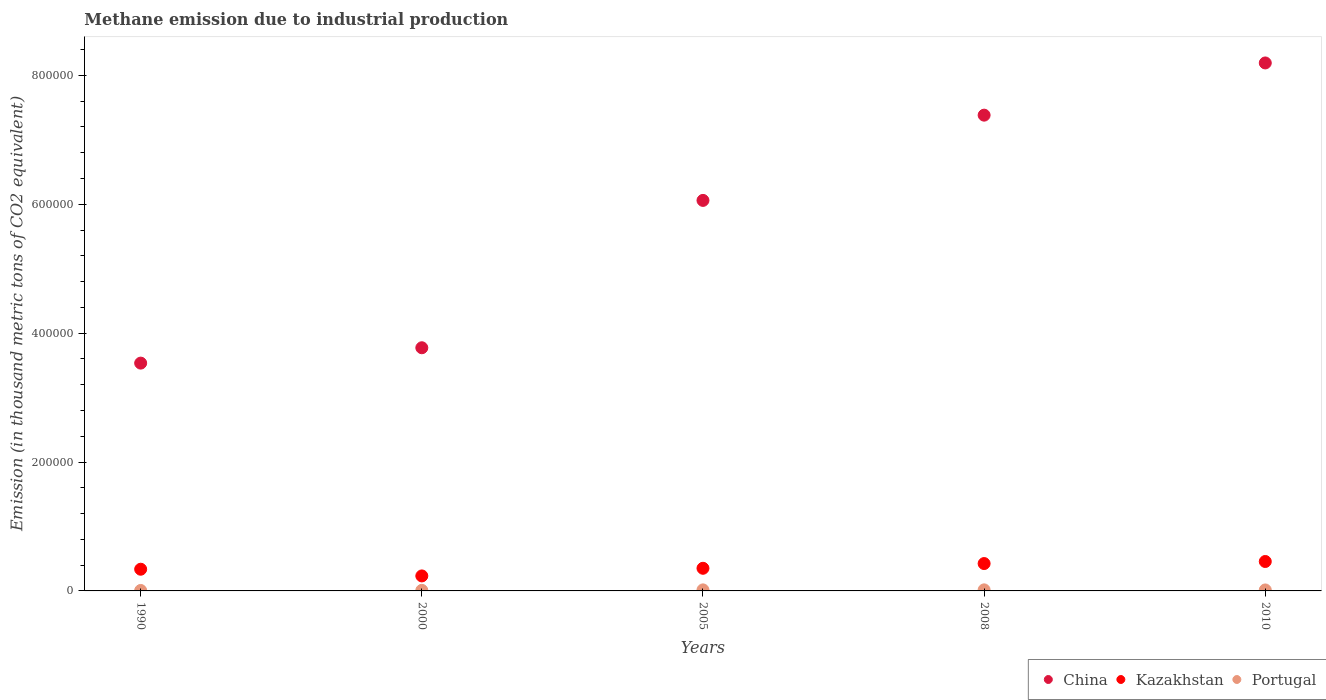What is the amount of methane emitted in China in 1990?
Give a very brief answer. 3.54e+05. Across all years, what is the maximum amount of methane emitted in Portugal?
Offer a terse response. 1651.1. Across all years, what is the minimum amount of methane emitted in Portugal?
Ensure brevity in your answer.  708.7. In which year was the amount of methane emitted in Kazakhstan minimum?
Ensure brevity in your answer.  2000. What is the total amount of methane emitted in Kazakhstan in the graph?
Your answer should be very brief. 1.80e+05. What is the difference between the amount of methane emitted in Kazakhstan in 1990 and that in 2008?
Make the answer very short. -8797.8. What is the difference between the amount of methane emitted in China in 2000 and the amount of methane emitted in Portugal in 2008?
Your answer should be compact. 3.76e+05. What is the average amount of methane emitted in Portugal per year?
Your response must be concise. 1279.18. In the year 1990, what is the difference between the amount of methane emitted in Kazakhstan and amount of methane emitted in China?
Give a very brief answer. -3.20e+05. In how many years, is the amount of methane emitted in Portugal greater than 600000 thousand metric tons?
Offer a very short reply. 0. What is the ratio of the amount of methane emitted in China in 2000 to that in 2008?
Provide a short and direct response. 0.51. Is the difference between the amount of methane emitted in Kazakhstan in 1990 and 2005 greater than the difference between the amount of methane emitted in China in 1990 and 2005?
Provide a succinct answer. Yes. What is the difference between the highest and the second highest amount of methane emitted in Portugal?
Your response must be concise. 36.1. What is the difference between the highest and the lowest amount of methane emitted in China?
Make the answer very short. 4.66e+05. In how many years, is the amount of methane emitted in Kazakhstan greater than the average amount of methane emitted in Kazakhstan taken over all years?
Keep it short and to the point. 2. Is the sum of the amount of methane emitted in Portugal in 1990 and 2000 greater than the maximum amount of methane emitted in Kazakhstan across all years?
Make the answer very short. No. Does the amount of methane emitted in China monotonically increase over the years?
Provide a succinct answer. Yes. Is the amount of methane emitted in Portugal strictly greater than the amount of methane emitted in Kazakhstan over the years?
Provide a short and direct response. No. Is the amount of methane emitted in China strictly less than the amount of methane emitted in Portugal over the years?
Offer a terse response. No. Are the values on the major ticks of Y-axis written in scientific E-notation?
Provide a succinct answer. No. Where does the legend appear in the graph?
Your response must be concise. Bottom right. How many legend labels are there?
Give a very brief answer. 3. How are the legend labels stacked?
Your answer should be compact. Horizontal. What is the title of the graph?
Provide a short and direct response. Methane emission due to industrial production. What is the label or title of the Y-axis?
Keep it short and to the point. Emission (in thousand metric tons of CO2 equivalent). What is the Emission (in thousand metric tons of CO2 equivalent) in China in 1990?
Ensure brevity in your answer.  3.54e+05. What is the Emission (in thousand metric tons of CO2 equivalent) in Kazakhstan in 1990?
Make the answer very short. 3.37e+04. What is the Emission (in thousand metric tons of CO2 equivalent) of Portugal in 1990?
Your answer should be very brief. 708.7. What is the Emission (in thousand metric tons of CO2 equivalent) of China in 2000?
Your response must be concise. 3.77e+05. What is the Emission (in thousand metric tons of CO2 equivalent) in Kazakhstan in 2000?
Make the answer very short. 2.33e+04. What is the Emission (in thousand metric tons of CO2 equivalent) of Portugal in 2000?
Make the answer very short. 909.6. What is the Emission (in thousand metric tons of CO2 equivalent) in China in 2005?
Ensure brevity in your answer.  6.06e+05. What is the Emission (in thousand metric tons of CO2 equivalent) of Kazakhstan in 2005?
Offer a terse response. 3.51e+04. What is the Emission (in thousand metric tons of CO2 equivalent) of Portugal in 2005?
Offer a very short reply. 1615. What is the Emission (in thousand metric tons of CO2 equivalent) of China in 2008?
Provide a succinct answer. 7.38e+05. What is the Emission (in thousand metric tons of CO2 equivalent) in Kazakhstan in 2008?
Ensure brevity in your answer.  4.25e+04. What is the Emission (in thousand metric tons of CO2 equivalent) of Portugal in 2008?
Your answer should be very brief. 1651.1. What is the Emission (in thousand metric tons of CO2 equivalent) in China in 2010?
Ensure brevity in your answer.  8.19e+05. What is the Emission (in thousand metric tons of CO2 equivalent) of Kazakhstan in 2010?
Keep it short and to the point. 4.57e+04. What is the Emission (in thousand metric tons of CO2 equivalent) in Portugal in 2010?
Your answer should be compact. 1511.5. Across all years, what is the maximum Emission (in thousand metric tons of CO2 equivalent) in China?
Keep it short and to the point. 8.19e+05. Across all years, what is the maximum Emission (in thousand metric tons of CO2 equivalent) in Kazakhstan?
Ensure brevity in your answer.  4.57e+04. Across all years, what is the maximum Emission (in thousand metric tons of CO2 equivalent) in Portugal?
Your answer should be very brief. 1651.1. Across all years, what is the minimum Emission (in thousand metric tons of CO2 equivalent) in China?
Provide a succinct answer. 3.54e+05. Across all years, what is the minimum Emission (in thousand metric tons of CO2 equivalent) of Kazakhstan?
Ensure brevity in your answer.  2.33e+04. Across all years, what is the minimum Emission (in thousand metric tons of CO2 equivalent) of Portugal?
Offer a very short reply. 708.7. What is the total Emission (in thousand metric tons of CO2 equivalent) of China in the graph?
Keep it short and to the point. 2.89e+06. What is the total Emission (in thousand metric tons of CO2 equivalent) of Kazakhstan in the graph?
Provide a succinct answer. 1.80e+05. What is the total Emission (in thousand metric tons of CO2 equivalent) of Portugal in the graph?
Your answer should be compact. 6395.9. What is the difference between the Emission (in thousand metric tons of CO2 equivalent) in China in 1990 and that in 2000?
Provide a succinct answer. -2.38e+04. What is the difference between the Emission (in thousand metric tons of CO2 equivalent) in Kazakhstan in 1990 and that in 2000?
Offer a terse response. 1.04e+04. What is the difference between the Emission (in thousand metric tons of CO2 equivalent) in Portugal in 1990 and that in 2000?
Give a very brief answer. -200.9. What is the difference between the Emission (in thousand metric tons of CO2 equivalent) in China in 1990 and that in 2005?
Your response must be concise. -2.53e+05. What is the difference between the Emission (in thousand metric tons of CO2 equivalent) of Kazakhstan in 1990 and that in 2005?
Make the answer very short. -1456.8. What is the difference between the Emission (in thousand metric tons of CO2 equivalent) in Portugal in 1990 and that in 2005?
Your response must be concise. -906.3. What is the difference between the Emission (in thousand metric tons of CO2 equivalent) of China in 1990 and that in 2008?
Offer a terse response. -3.85e+05. What is the difference between the Emission (in thousand metric tons of CO2 equivalent) in Kazakhstan in 1990 and that in 2008?
Keep it short and to the point. -8797.8. What is the difference between the Emission (in thousand metric tons of CO2 equivalent) of Portugal in 1990 and that in 2008?
Provide a short and direct response. -942.4. What is the difference between the Emission (in thousand metric tons of CO2 equivalent) of China in 1990 and that in 2010?
Provide a succinct answer. -4.66e+05. What is the difference between the Emission (in thousand metric tons of CO2 equivalent) of Kazakhstan in 1990 and that in 2010?
Make the answer very short. -1.20e+04. What is the difference between the Emission (in thousand metric tons of CO2 equivalent) of Portugal in 1990 and that in 2010?
Provide a short and direct response. -802.8. What is the difference between the Emission (in thousand metric tons of CO2 equivalent) of China in 2000 and that in 2005?
Your answer should be very brief. -2.29e+05. What is the difference between the Emission (in thousand metric tons of CO2 equivalent) of Kazakhstan in 2000 and that in 2005?
Provide a succinct answer. -1.19e+04. What is the difference between the Emission (in thousand metric tons of CO2 equivalent) of Portugal in 2000 and that in 2005?
Ensure brevity in your answer.  -705.4. What is the difference between the Emission (in thousand metric tons of CO2 equivalent) of China in 2000 and that in 2008?
Your answer should be very brief. -3.61e+05. What is the difference between the Emission (in thousand metric tons of CO2 equivalent) in Kazakhstan in 2000 and that in 2008?
Your answer should be compact. -1.92e+04. What is the difference between the Emission (in thousand metric tons of CO2 equivalent) in Portugal in 2000 and that in 2008?
Provide a succinct answer. -741.5. What is the difference between the Emission (in thousand metric tons of CO2 equivalent) in China in 2000 and that in 2010?
Offer a very short reply. -4.42e+05. What is the difference between the Emission (in thousand metric tons of CO2 equivalent) in Kazakhstan in 2000 and that in 2010?
Keep it short and to the point. -2.24e+04. What is the difference between the Emission (in thousand metric tons of CO2 equivalent) in Portugal in 2000 and that in 2010?
Your response must be concise. -601.9. What is the difference between the Emission (in thousand metric tons of CO2 equivalent) in China in 2005 and that in 2008?
Give a very brief answer. -1.32e+05. What is the difference between the Emission (in thousand metric tons of CO2 equivalent) of Kazakhstan in 2005 and that in 2008?
Offer a very short reply. -7341. What is the difference between the Emission (in thousand metric tons of CO2 equivalent) of Portugal in 2005 and that in 2008?
Offer a terse response. -36.1. What is the difference between the Emission (in thousand metric tons of CO2 equivalent) in China in 2005 and that in 2010?
Give a very brief answer. -2.13e+05. What is the difference between the Emission (in thousand metric tons of CO2 equivalent) in Kazakhstan in 2005 and that in 2010?
Make the answer very short. -1.05e+04. What is the difference between the Emission (in thousand metric tons of CO2 equivalent) of Portugal in 2005 and that in 2010?
Keep it short and to the point. 103.5. What is the difference between the Emission (in thousand metric tons of CO2 equivalent) in China in 2008 and that in 2010?
Offer a terse response. -8.10e+04. What is the difference between the Emission (in thousand metric tons of CO2 equivalent) of Kazakhstan in 2008 and that in 2010?
Make the answer very short. -3195. What is the difference between the Emission (in thousand metric tons of CO2 equivalent) in Portugal in 2008 and that in 2010?
Offer a very short reply. 139.6. What is the difference between the Emission (in thousand metric tons of CO2 equivalent) of China in 1990 and the Emission (in thousand metric tons of CO2 equivalent) of Kazakhstan in 2000?
Keep it short and to the point. 3.30e+05. What is the difference between the Emission (in thousand metric tons of CO2 equivalent) in China in 1990 and the Emission (in thousand metric tons of CO2 equivalent) in Portugal in 2000?
Your answer should be compact. 3.53e+05. What is the difference between the Emission (in thousand metric tons of CO2 equivalent) in Kazakhstan in 1990 and the Emission (in thousand metric tons of CO2 equivalent) in Portugal in 2000?
Your response must be concise. 3.28e+04. What is the difference between the Emission (in thousand metric tons of CO2 equivalent) of China in 1990 and the Emission (in thousand metric tons of CO2 equivalent) of Kazakhstan in 2005?
Give a very brief answer. 3.18e+05. What is the difference between the Emission (in thousand metric tons of CO2 equivalent) in China in 1990 and the Emission (in thousand metric tons of CO2 equivalent) in Portugal in 2005?
Your response must be concise. 3.52e+05. What is the difference between the Emission (in thousand metric tons of CO2 equivalent) of Kazakhstan in 1990 and the Emission (in thousand metric tons of CO2 equivalent) of Portugal in 2005?
Keep it short and to the point. 3.21e+04. What is the difference between the Emission (in thousand metric tons of CO2 equivalent) of China in 1990 and the Emission (in thousand metric tons of CO2 equivalent) of Kazakhstan in 2008?
Your response must be concise. 3.11e+05. What is the difference between the Emission (in thousand metric tons of CO2 equivalent) in China in 1990 and the Emission (in thousand metric tons of CO2 equivalent) in Portugal in 2008?
Offer a terse response. 3.52e+05. What is the difference between the Emission (in thousand metric tons of CO2 equivalent) of Kazakhstan in 1990 and the Emission (in thousand metric tons of CO2 equivalent) of Portugal in 2008?
Provide a succinct answer. 3.20e+04. What is the difference between the Emission (in thousand metric tons of CO2 equivalent) in China in 1990 and the Emission (in thousand metric tons of CO2 equivalent) in Kazakhstan in 2010?
Offer a terse response. 3.08e+05. What is the difference between the Emission (in thousand metric tons of CO2 equivalent) in China in 1990 and the Emission (in thousand metric tons of CO2 equivalent) in Portugal in 2010?
Keep it short and to the point. 3.52e+05. What is the difference between the Emission (in thousand metric tons of CO2 equivalent) of Kazakhstan in 1990 and the Emission (in thousand metric tons of CO2 equivalent) of Portugal in 2010?
Keep it short and to the point. 3.22e+04. What is the difference between the Emission (in thousand metric tons of CO2 equivalent) in China in 2000 and the Emission (in thousand metric tons of CO2 equivalent) in Kazakhstan in 2005?
Keep it short and to the point. 3.42e+05. What is the difference between the Emission (in thousand metric tons of CO2 equivalent) of China in 2000 and the Emission (in thousand metric tons of CO2 equivalent) of Portugal in 2005?
Your answer should be compact. 3.76e+05. What is the difference between the Emission (in thousand metric tons of CO2 equivalent) of Kazakhstan in 2000 and the Emission (in thousand metric tons of CO2 equivalent) of Portugal in 2005?
Your answer should be very brief. 2.17e+04. What is the difference between the Emission (in thousand metric tons of CO2 equivalent) of China in 2000 and the Emission (in thousand metric tons of CO2 equivalent) of Kazakhstan in 2008?
Provide a short and direct response. 3.35e+05. What is the difference between the Emission (in thousand metric tons of CO2 equivalent) of China in 2000 and the Emission (in thousand metric tons of CO2 equivalent) of Portugal in 2008?
Your answer should be compact. 3.76e+05. What is the difference between the Emission (in thousand metric tons of CO2 equivalent) in Kazakhstan in 2000 and the Emission (in thousand metric tons of CO2 equivalent) in Portugal in 2008?
Your answer should be compact. 2.16e+04. What is the difference between the Emission (in thousand metric tons of CO2 equivalent) in China in 2000 and the Emission (in thousand metric tons of CO2 equivalent) in Kazakhstan in 2010?
Provide a succinct answer. 3.32e+05. What is the difference between the Emission (in thousand metric tons of CO2 equivalent) of China in 2000 and the Emission (in thousand metric tons of CO2 equivalent) of Portugal in 2010?
Your response must be concise. 3.76e+05. What is the difference between the Emission (in thousand metric tons of CO2 equivalent) in Kazakhstan in 2000 and the Emission (in thousand metric tons of CO2 equivalent) in Portugal in 2010?
Offer a very short reply. 2.18e+04. What is the difference between the Emission (in thousand metric tons of CO2 equivalent) of China in 2005 and the Emission (in thousand metric tons of CO2 equivalent) of Kazakhstan in 2008?
Give a very brief answer. 5.64e+05. What is the difference between the Emission (in thousand metric tons of CO2 equivalent) of China in 2005 and the Emission (in thousand metric tons of CO2 equivalent) of Portugal in 2008?
Give a very brief answer. 6.04e+05. What is the difference between the Emission (in thousand metric tons of CO2 equivalent) in Kazakhstan in 2005 and the Emission (in thousand metric tons of CO2 equivalent) in Portugal in 2008?
Your response must be concise. 3.35e+04. What is the difference between the Emission (in thousand metric tons of CO2 equivalent) of China in 2005 and the Emission (in thousand metric tons of CO2 equivalent) of Kazakhstan in 2010?
Give a very brief answer. 5.60e+05. What is the difference between the Emission (in thousand metric tons of CO2 equivalent) of China in 2005 and the Emission (in thousand metric tons of CO2 equivalent) of Portugal in 2010?
Give a very brief answer. 6.04e+05. What is the difference between the Emission (in thousand metric tons of CO2 equivalent) in Kazakhstan in 2005 and the Emission (in thousand metric tons of CO2 equivalent) in Portugal in 2010?
Give a very brief answer. 3.36e+04. What is the difference between the Emission (in thousand metric tons of CO2 equivalent) of China in 2008 and the Emission (in thousand metric tons of CO2 equivalent) of Kazakhstan in 2010?
Give a very brief answer. 6.93e+05. What is the difference between the Emission (in thousand metric tons of CO2 equivalent) of China in 2008 and the Emission (in thousand metric tons of CO2 equivalent) of Portugal in 2010?
Offer a very short reply. 7.37e+05. What is the difference between the Emission (in thousand metric tons of CO2 equivalent) of Kazakhstan in 2008 and the Emission (in thousand metric tons of CO2 equivalent) of Portugal in 2010?
Your answer should be compact. 4.10e+04. What is the average Emission (in thousand metric tons of CO2 equivalent) in China per year?
Offer a very short reply. 5.79e+05. What is the average Emission (in thousand metric tons of CO2 equivalent) of Kazakhstan per year?
Your response must be concise. 3.60e+04. What is the average Emission (in thousand metric tons of CO2 equivalent) in Portugal per year?
Keep it short and to the point. 1279.18. In the year 1990, what is the difference between the Emission (in thousand metric tons of CO2 equivalent) in China and Emission (in thousand metric tons of CO2 equivalent) in Kazakhstan?
Provide a short and direct response. 3.20e+05. In the year 1990, what is the difference between the Emission (in thousand metric tons of CO2 equivalent) in China and Emission (in thousand metric tons of CO2 equivalent) in Portugal?
Offer a terse response. 3.53e+05. In the year 1990, what is the difference between the Emission (in thousand metric tons of CO2 equivalent) in Kazakhstan and Emission (in thousand metric tons of CO2 equivalent) in Portugal?
Your answer should be compact. 3.30e+04. In the year 2000, what is the difference between the Emission (in thousand metric tons of CO2 equivalent) of China and Emission (in thousand metric tons of CO2 equivalent) of Kazakhstan?
Make the answer very short. 3.54e+05. In the year 2000, what is the difference between the Emission (in thousand metric tons of CO2 equivalent) of China and Emission (in thousand metric tons of CO2 equivalent) of Portugal?
Keep it short and to the point. 3.76e+05. In the year 2000, what is the difference between the Emission (in thousand metric tons of CO2 equivalent) of Kazakhstan and Emission (in thousand metric tons of CO2 equivalent) of Portugal?
Make the answer very short. 2.24e+04. In the year 2005, what is the difference between the Emission (in thousand metric tons of CO2 equivalent) in China and Emission (in thousand metric tons of CO2 equivalent) in Kazakhstan?
Provide a short and direct response. 5.71e+05. In the year 2005, what is the difference between the Emission (in thousand metric tons of CO2 equivalent) of China and Emission (in thousand metric tons of CO2 equivalent) of Portugal?
Your answer should be very brief. 6.04e+05. In the year 2005, what is the difference between the Emission (in thousand metric tons of CO2 equivalent) of Kazakhstan and Emission (in thousand metric tons of CO2 equivalent) of Portugal?
Provide a succinct answer. 3.35e+04. In the year 2008, what is the difference between the Emission (in thousand metric tons of CO2 equivalent) of China and Emission (in thousand metric tons of CO2 equivalent) of Kazakhstan?
Give a very brief answer. 6.96e+05. In the year 2008, what is the difference between the Emission (in thousand metric tons of CO2 equivalent) of China and Emission (in thousand metric tons of CO2 equivalent) of Portugal?
Provide a succinct answer. 7.37e+05. In the year 2008, what is the difference between the Emission (in thousand metric tons of CO2 equivalent) of Kazakhstan and Emission (in thousand metric tons of CO2 equivalent) of Portugal?
Your answer should be very brief. 4.08e+04. In the year 2010, what is the difference between the Emission (in thousand metric tons of CO2 equivalent) in China and Emission (in thousand metric tons of CO2 equivalent) in Kazakhstan?
Provide a succinct answer. 7.74e+05. In the year 2010, what is the difference between the Emission (in thousand metric tons of CO2 equivalent) of China and Emission (in thousand metric tons of CO2 equivalent) of Portugal?
Your answer should be compact. 8.18e+05. In the year 2010, what is the difference between the Emission (in thousand metric tons of CO2 equivalent) in Kazakhstan and Emission (in thousand metric tons of CO2 equivalent) in Portugal?
Give a very brief answer. 4.42e+04. What is the ratio of the Emission (in thousand metric tons of CO2 equivalent) in China in 1990 to that in 2000?
Your response must be concise. 0.94. What is the ratio of the Emission (in thousand metric tons of CO2 equivalent) of Kazakhstan in 1990 to that in 2000?
Give a very brief answer. 1.45. What is the ratio of the Emission (in thousand metric tons of CO2 equivalent) of Portugal in 1990 to that in 2000?
Ensure brevity in your answer.  0.78. What is the ratio of the Emission (in thousand metric tons of CO2 equivalent) of China in 1990 to that in 2005?
Offer a very short reply. 0.58. What is the ratio of the Emission (in thousand metric tons of CO2 equivalent) in Kazakhstan in 1990 to that in 2005?
Provide a succinct answer. 0.96. What is the ratio of the Emission (in thousand metric tons of CO2 equivalent) in Portugal in 1990 to that in 2005?
Your answer should be very brief. 0.44. What is the ratio of the Emission (in thousand metric tons of CO2 equivalent) of China in 1990 to that in 2008?
Your answer should be very brief. 0.48. What is the ratio of the Emission (in thousand metric tons of CO2 equivalent) in Kazakhstan in 1990 to that in 2008?
Provide a short and direct response. 0.79. What is the ratio of the Emission (in thousand metric tons of CO2 equivalent) of Portugal in 1990 to that in 2008?
Your answer should be very brief. 0.43. What is the ratio of the Emission (in thousand metric tons of CO2 equivalent) in China in 1990 to that in 2010?
Provide a short and direct response. 0.43. What is the ratio of the Emission (in thousand metric tons of CO2 equivalent) in Kazakhstan in 1990 to that in 2010?
Your answer should be compact. 0.74. What is the ratio of the Emission (in thousand metric tons of CO2 equivalent) of Portugal in 1990 to that in 2010?
Your answer should be compact. 0.47. What is the ratio of the Emission (in thousand metric tons of CO2 equivalent) of China in 2000 to that in 2005?
Offer a terse response. 0.62. What is the ratio of the Emission (in thousand metric tons of CO2 equivalent) of Kazakhstan in 2000 to that in 2005?
Give a very brief answer. 0.66. What is the ratio of the Emission (in thousand metric tons of CO2 equivalent) in Portugal in 2000 to that in 2005?
Provide a succinct answer. 0.56. What is the ratio of the Emission (in thousand metric tons of CO2 equivalent) of China in 2000 to that in 2008?
Ensure brevity in your answer.  0.51. What is the ratio of the Emission (in thousand metric tons of CO2 equivalent) in Kazakhstan in 2000 to that in 2008?
Provide a succinct answer. 0.55. What is the ratio of the Emission (in thousand metric tons of CO2 equivalent) in Portugal in 2000 to that in 2008?
Make the answer very short. 0.55. What is the ratio of the Emission (in thousand metric tons of CO2 equivalent) in China in 2000 to that in 2010?
Keep it short and to the point. 0.46. What is the ratio of the Emission (in thousand metric tons of CO2 equivalent) of Kazakhstan in 2000 to that in 2010?
Your response must be concise. 0.51. What is the ratio of the Emission (in thousand metric tons of CO2 equivalent) of Portugal in 2000 to that in 2010?
Your response must be concise. 0.6. What is the ratio of the Emission (in thousand metric tons of CO2 equivalent) of China in 2005 to that in 2008?
Give a very brief answer. 0.82. What is the ratio of the Emission (in thousand metric tons of CO2 equivalent) of Kazakhstan in 2005 to that in 2008?
Give a very brief answer. 0.83. What is the ratio of the Emission (in thousand metric tons of CO2 equivalent) of Portugal in 2005 to that in 2008?
Your answer should be very brief. 0.98. What is the ratio of the Emission (in thousand metric tons of CO2 equivalent) of China in 2005 to that in 2010?
Your answer should be very brief. 0.74. What is the ratio of the Emission (in thousand metric tons of CO2 equivalent) of Kazakhstan in 2005 to that in 2010?
Make the answer very short. 0.77. What is the ratio of the Emission (in thousand metric tons of CO2 equivalent) in Portugal in 2005 to that in 2010?
Your response must be concise. 1.07. What is the ratio of the Emission (in thousand metric tons of CO2 equivalent) of China in 2008 to that in 2010?
Make the answer very short. 0.9. What is the ratio of the Emission (in thousand metric tons of CO2 equivalent) in Portugal in 2008 to that in 2010?
Provide a succinct answer. 1.09. What is the difference between the highest and the second highest Emission (in thousand metric tons of CO2 equivalent) of China?
Ensure brevity in your answer.  8.10e+04. What is the difference between the highest and the second highest Emission (in thousand metric tons of CO2 equivalent) of Kazakhstan?
Make the answer very short. 3195. What is the difference between the highest and the second highest Emission (in thousand metric tons of CO2 equivalent) in Portugal?
Provide a short and direct response. 36.1. What is the difference between the highest and the lowest Emission (in thousand metric tons of CO2 equivalent) of China?
Ensure brevity in your answer.  4.66e+05. What is the difference between the highest and the lowest Emission (in thousand metric tons of CO2 equivalent) of Kazakhstan?
Your answer should be compact. 2.24e+04. What is the difference between the highest and the lowest Emission (in thousand metric tons of CO2 equivalent) in Portugal?
Make the answer very short. 942.4. 